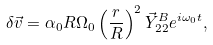Convert formula to latex. <formula><loc_0><loc_0><loc_500><loc_500>\delta \vec { v } = \alpha _ { 0 } R \Omega _ { 0 } \left ( \frac { r } { R } \right ) ^ { 2 } \vec { Y } ^ { B } _ { 2 2 } e ^ { i \omega _ { 0 } t } ,</formula> 